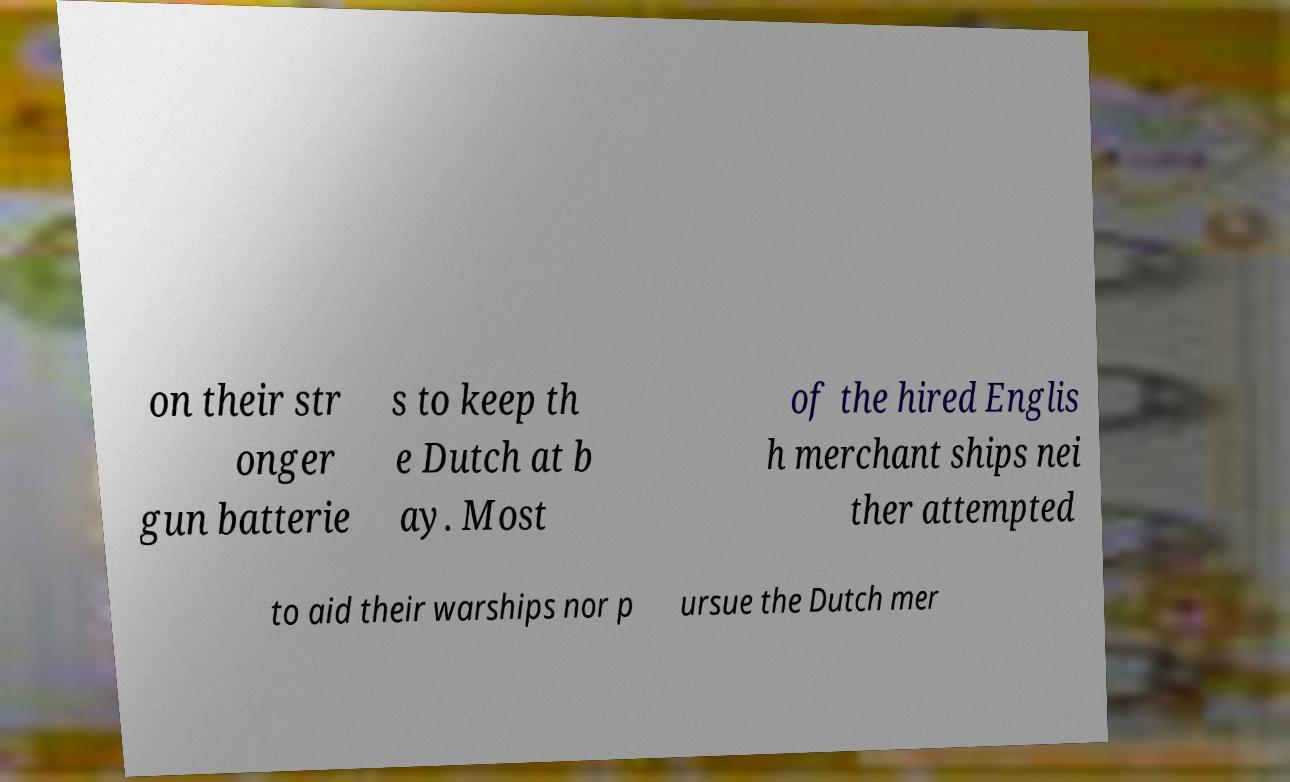Could you extract and type out the text from this image? on their str onger gun batterie s to keep th e Dutch at b ay. Most of the hired Englis h merchant ships nei ther attempted to aid their warships nor p ursue the Dutch mer 